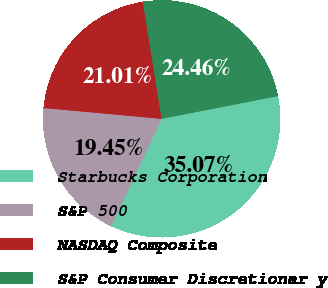<chart> <loc_0><loc_0><loc_500><loc_500><pie_chart><fcel>Starbucks Corporation<fcel>S&P 500<fcel>NASDAQ Composite<fcel>S&P Consumer Discretionar y<nl><fcel>35.07%<fcel>19.45%<fcel>21.01%<fcel>24.46%<nl></chart> 